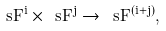<formula> <loc_0><loc_0><loc_500><loc_500>\ s F ^ { i } \times \ s F ^ { j } \to \ s F ^ { ( i + j ) } ,</formula> 